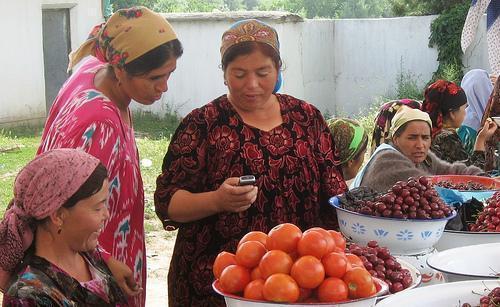The largest food item on any of these tables is found in what sauce?
From the following four choices, select the correct answer to address the question.
Options: Duck, ketchup, soy, mustard. Ketchup. 